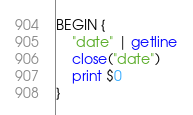Convert code to text. <code><loc_0><loc_0><loc_500><loc_500><_Awk_>BEGIN {
    "date" | getline
    close("date")
    print $0
}
</code> 